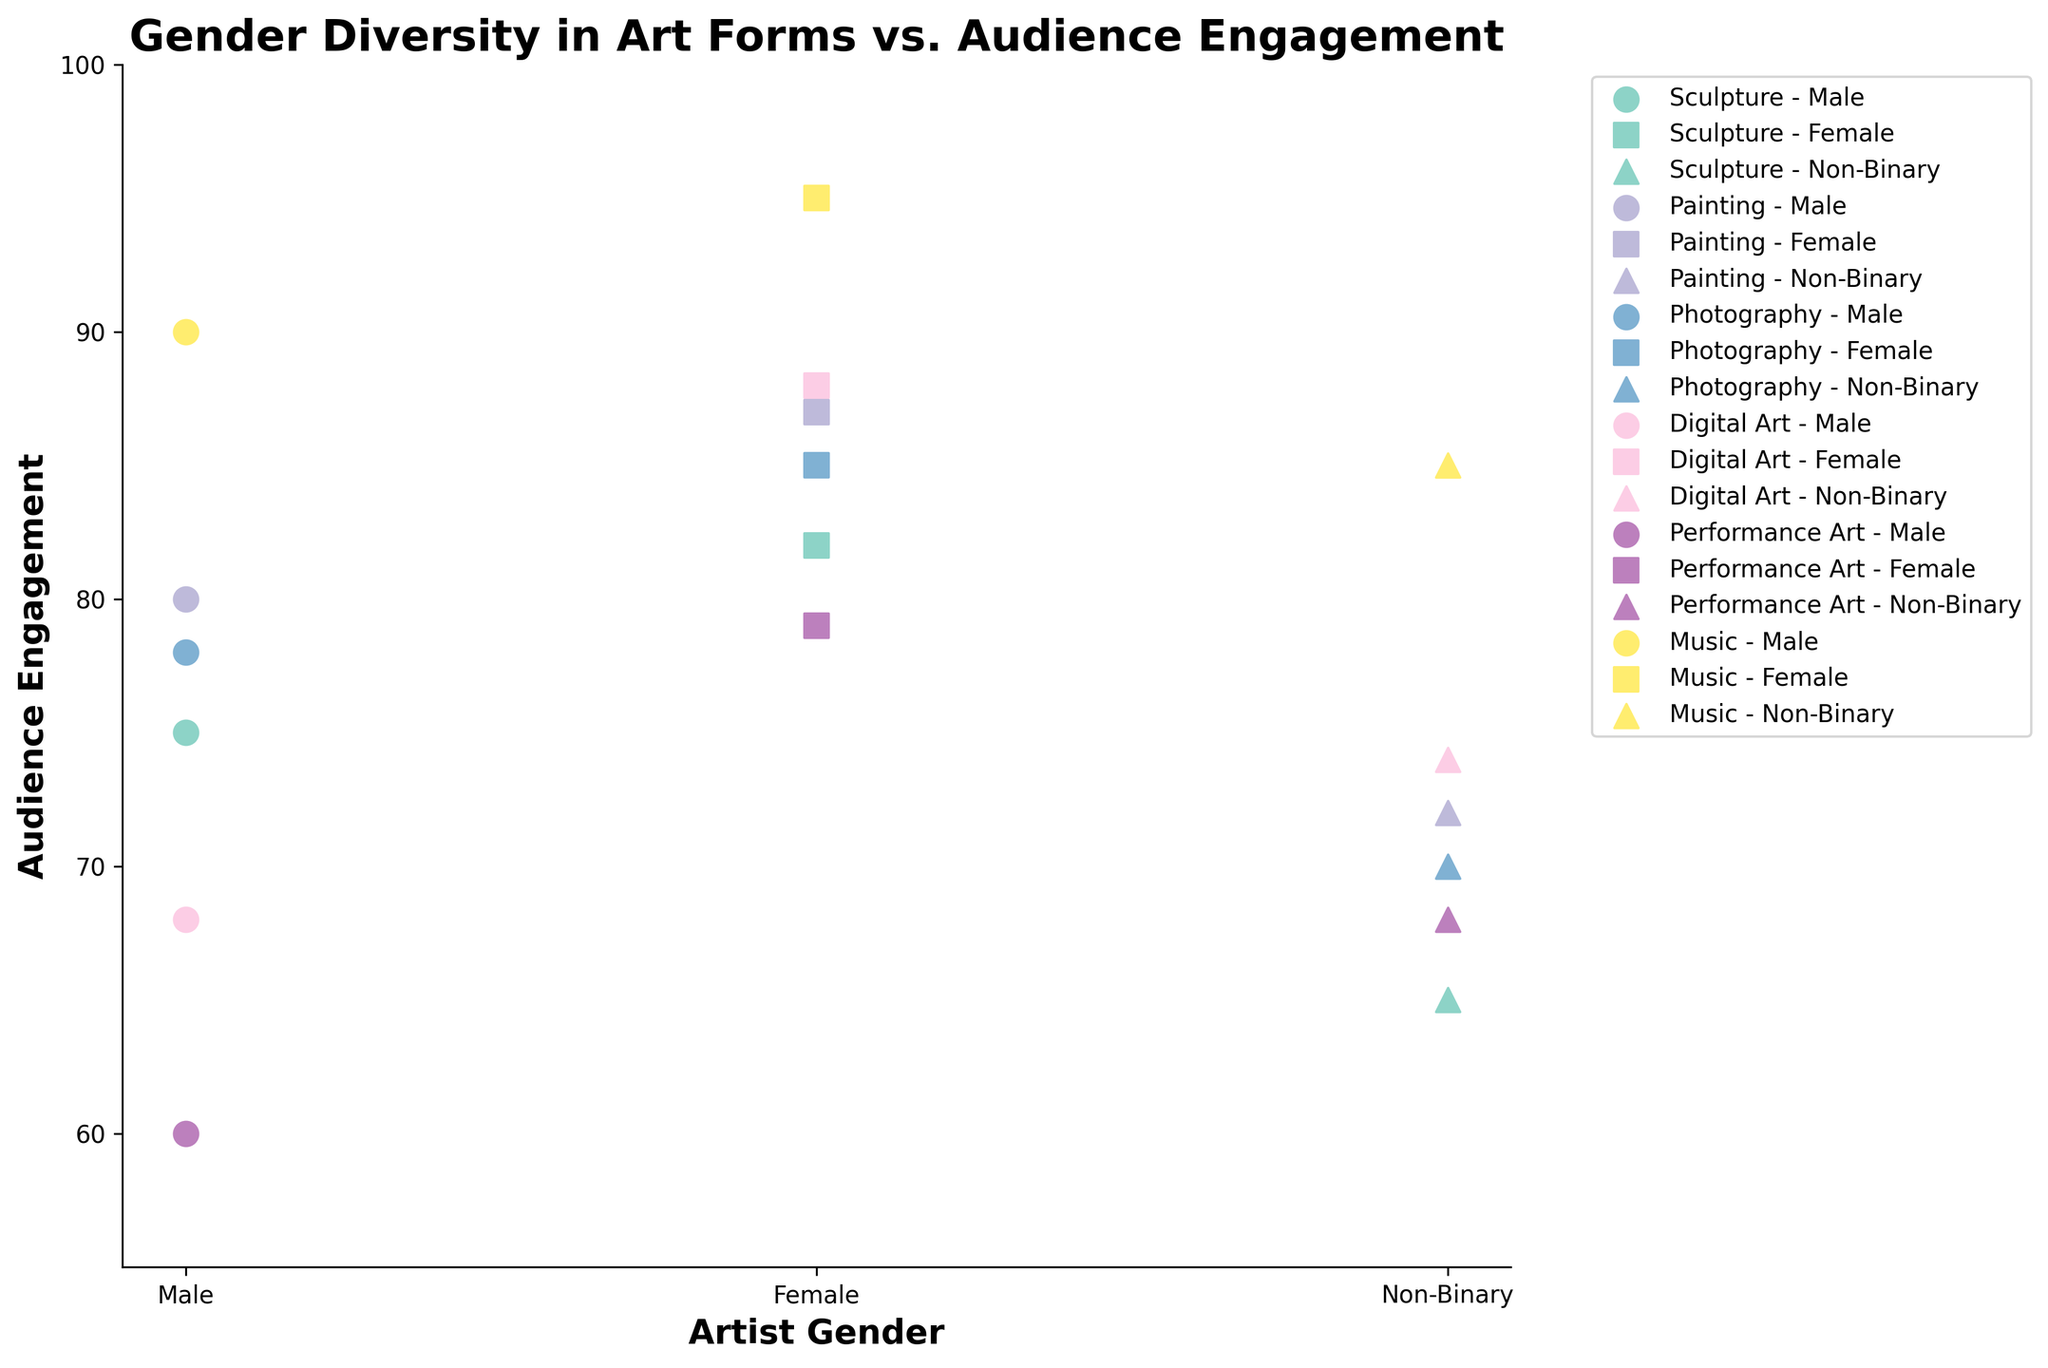What is the title of the figure? The title of the figure is located at the top and typically summarizes the main theme of the chart. In this case, it explains the topic of gender diversity within art forms and how it correlates with audience engagement.
Answer: Gender Diversity in Art Forms vs. Audience Engagement What are the axes labels of the figure? The axes labels are crucial for understanding what each axis represents. The x-axis label provides information about the categories of interest, while the y-axis label quantifies the measured data.
Answer: The x-axis is labeled 'Artist Gender' and the y-axis is labeled 'Audience Engagement' Which art form has the highest audience engagement for female artists? To find this, we look for the highest y-value corresponding to female artists across all art forms depicted in different colors and markers.
Answer: Digital Art What is the range of audience engagement for male artists across all art forms? The range is the difference between the maximum and minimum values of audience engagement for male artists within the dataset.
Answer: The range is 90 - 60 = 30 Which group in Music has the highest engagement? To answer this, observe the data points in the Music category and identify which gender has the highest y-value.
Answer: Female Compare the audience engagement between male and female artists in Performance Art. Who has higher engagement and what's the difference? Find the y-values for male and female artists in Performance Art and calculate the difference.
Answer: Female artists have higher engagement. The difference is 79 - 60 = 19 What is the average audience engagement for non-binary artists across all art forms? To find the average, sum up all the audience engagement values for non-binary artists and divide by the number of art forms.
Answer: (65 + 72 + 70 + 74 + 68 + 85) / 6 = 72.33 How many art forms are represented in the figure? Count the distinct values of art forms along the x-axis or in the legend.
Answer: 6 Which gender has the lowest engagement in Digital Art and what is the engagement value? Locate the markers for Digital Art, and identify the gender with the lowest y-value.
Answer: Male, with an engagement value of 68 In which art form is the gap between male and female artists' engagement largest? What is that gap? Calculate the difference between male and female engagement values for each art form and identify the largest difference.
Answer: Digital Art, with a gap of 88 - 68 = 20 